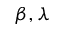Convert formula to latex. <formula><loc_0><loc_0><loc_500><loc_500>\beta , \lambda</formula> 